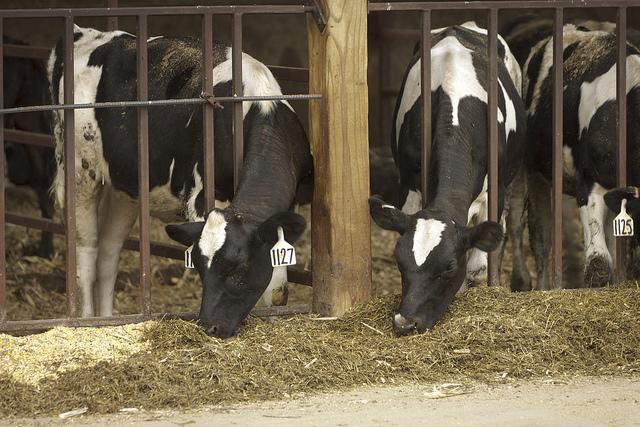What are the cows doing? The cows are eating hay or other feed that has been laid out for them. 